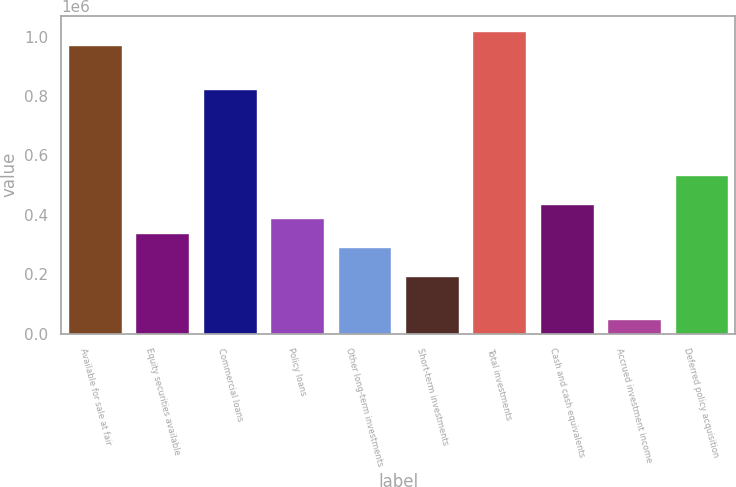Convert chart to OTSL. <chart><loc_0><loc_0><loc_500><loc_500><bar_chart><fcel>Available for sale at fair<fcel>Equity securities available<fcel>Commercial loans<fcel>Policy loans<fcel>Other long-term investments<fcel>Short-term investments<fcel>Total investments<fcel>Cash and cash equivalents<fcel>Accrued investment income<fcel>Deferred policy acquisition<nl><fcel>971181<fcel>340204<fcel>825571<fcel>388741<fcel>291667<fcel>194594<fcel>1.01972e+06<fcel>437277<fcel>48983.7<fcel>534351<nl></chart> 